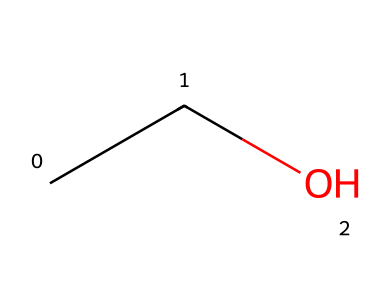What is the name of this chemical? Based on the SMILES representation "CCO", the chemical corresponds to ethanol, which is a common name for the compound with two carbon atoms, five hydrogen atoms, and one oxygen atom.
Answer: ethanol How many carbon atoms are present in this structure? In the SMILES "CCO", the first two letters "CC" indicate the presence of two carbon atoms.
Answer: two What is the functional group found in this molecule? Ethanol has a hydroxyl group represented by the "O" in the SMILES, indicating that it is an alcohol. The presence of the O atom attached to a carbon chain represents the functional group.
Answer: hydroxyl What is the total number of hydrogen atoms in ethanol? The chemical structure indicated by "CCO" confirms that ethanol has a total of six hydrogen atoms; there are five from the carbon chain and one from the hydroxyl group.
Answer: six What type of chemical is ethanol classified as? Ethanol, as derived from the SMILES "CCO", is classified as an alcohol because of its hydroxyl functional group attached to a saturated carbon chain.
Answer: alcohol How many single bonds are in the molecular structure of ethanol? Analyzing the SMILES "CCO", there are four single bonds connecting the atoms: between the carbon-carbon and carbon-oxygen, including the hydrogen connections.
Answer: four Is this molecule polar or nonpolar? Considering the presence of the hydroxyl group in ethanol, the molecule displays polarity due to the electronegative oxygen atom, which gives the molecule its polar characteristics.
Answer: polar 